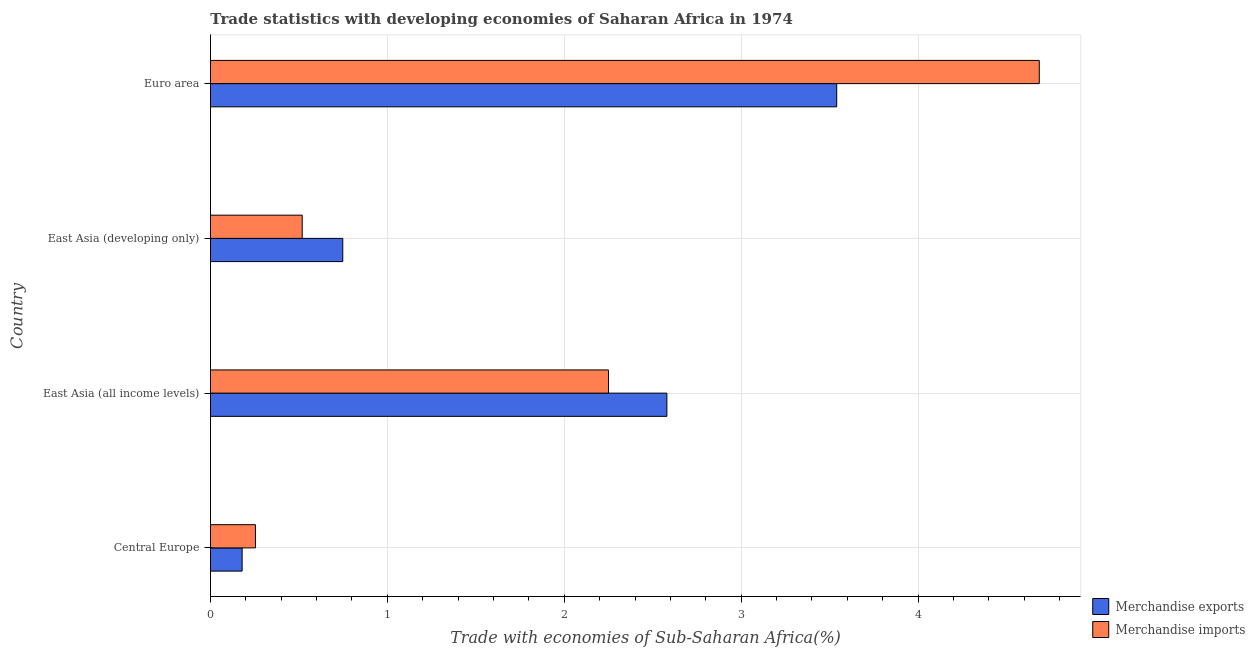How many groups of bars are there?
Offer a terse response. 4. Are the number of bars per tick equal to the number of legend labels?
Your answer should be very brief. Yes. Are the number of bars on each tick of the Y-axis equal?
Provide a short and direct response. Yes. How many bars are there on the 3rd tick from the bottom?
Offer a terse response. 2. What is the label of the 2nd group of bars from the top?
Offer a terse response. East Asia (developing only). In how many cases, is the number of bars for a given country not equal to the number of legend labels?
Provide a succinct answer. 0. What is the merchandise imports in Euro area?
Your answer should be very brief. 4.69. Across all countries, what is the maximum merchandise exports?
Ensure brevity in your answer.  3.54. Across all countries, what is the minimum merchandise imports?
Provide a short and direct response. 0.25. In which country was the merchandise imports minimum?
Make the answer very short. Central Europe. What is the total merchandise imports in the graph?
Provide a succinct answer. 7.71. What is the difference between the merchandise imports in East Asia (all income levels) and that in Euro area?
Your answer should be compact. -2.44. What is the difference between the merchandise imports in East Asia (all income levels) and the merchandise exports in East Asia (developing only)?
Your response must be concise. 1.5. What is the average merchandise exports per country?
Make the answer very short. 1.76. What is the difference between the merchandise imports and merchandise exports in Central Europe?
Keep it short and to the point. 0.07. What is the ratio of the merchandise exports in Central Europe to that in East Asia (all income levels)?
Offer a very short reply. 0.07. Is the difference between the merchandise imports in East Asia (all income levels) and East Asia (developing only) greater than the difference between the merchandise exports in East Asia (all income levels) and East Asia (developing only)?
Give a very brief answer. No. What is the difference between the highest and the second highest merchandise exports?
Your answer should be very brief. 0.96. What is the difference between the highest and the lowest merchandise exports?
Your answer should be compact. 3.36. Is the sum of the merchandise exports in Central Europe and Euro area greater than the maximum merchandise imports across all countries?
Your answer should be very brief. No. What does the 2nd bar from the top in East Asia (all income levels) represents?
Keep it short and to the point. Merchandise exports. How many bars are there?
Your answer should be very brief. 8. Are all the bars in the graph horizontal?
Keep it short and to the point. Yes. What is the difference between two consecutive major ticks on the X-axis?
Keep it short and to the point. 1. Are the values on the major ticks of X-axis written in scientific E-notation?
Provide a short and direct response. No. Does the graph contain any zero values?
Offer a terse response. No. Does the graph contain grids?
Give a very brief answer. Yes. How many legend labels are there?
Provide a short and direct response. 2. How are the legend labels stacked?
Your answer should be very brief. Vertical. What is the title of the graph?
Provide a short and direct response. Trade statistics with developing economies of Saharan Africa in 1974. What is the label or title of the X-axis?
Keep it short and to the point. Trade with economies of Sub-Saharan Africa(%). What is the label or title of the Y-axis?
Offer a terse response. Country. What is the Trade with economies of Sub-Saharan Africa(%) of Merchandise exports in Central Europe?
Offer a terse response. 0.18. What is the Trade with economies of Sub-Saharan Africa(%) in Merchandise imports in Central Europe?
Keep it short and to the point. 0.25. What is the Trade with economies of Sub-Saharan Africa(%) of Merchandise exports in East Asia (all income levels)?
Offer a terse response. 2.58. What is the Trade with economies of Sub-Saharan Africa(%) of Merchandise imports in East Asia (all income levels)?
Make the answer very short. 2.25. What is the Trade with economies of Sub-Saharan Africa(%) in Merchandise exports in East Asia (developing only)?
Make the answer very short. 0.75. What is the Trade with economies of Sub-Saharan Africa(%) in Merchandise imports in East Asia (developing only)?
Offer a very short reply. 0.52. What is the Trade with economies of Sub-Saharan Africa(%) of Merchandise exports in Euro area?
Your answer should be compact. 3.54. What is the Trade with economies of Sub-Saharan Africa(%) in Merchandise imports in Euro area?
Your answer should be compact. 4.69. Across all countries, what is the maximum Trade with economies of Sub-Saharan Africa(%) in Merchandise exports?
Your answer should be very brief. 3.54. Across all countries, what is the maximum Trade with economies of Sub-Saharan Africa(%) in Merchandise imports?
Provide a succinct answer. 4.69. Across all countries, what is the minimum Trade with economies of Sub-Saharan Africa(%) in Merchandise exports?
Ensure brevity in your answer.  0.18. Across all countries, what is the minimum Trade with economies of Sub-Saharan Africa(%) of Merchandise imports?
Offer a very short reply. 0.25. What is the total Trade with economies of Sub-Saharan Africa(%) in Merchandise exports in the graph?
Your response must be concise. 7.05. What is the total Trade with economies of Sub-Saharan Africa(%) of Merchandise imports in the graph?
Offer a very short reply. 7.71. What is the difference between the Trade with economies of Sub-Saharan Africa(%) of Merchandise exports in Central Europe and that in East Asia (all income levels)?
Give a very brief answer. -2.4. What is the difference between the Trade with economies of Sub-Saharan Africa(%) of Merchandise imports in Central Europe and that in East Asia (all income levels)?
Provide a succinct answer. -2. What is the difference between the Trade with economies of Sub-Saharan Africa(%) in Merchandise exports in Central Europe and that in East Asia (developing only)?
Your answer should be compact. -0.57. What is the difference between the Trade with economies of Sub-Saharan Africa(%) in Merchandise imports in Central Europe and that in East Asia (developing only)?
Make the answer very short. -0.26. What is the difference between the Trade with economies of Sub-Saharan Africa(%) of Merchandise exports in Central Europe and that in Euro area?
Make the answer very short. -3.36. What is the difference between the Trade with economies of Sub-Saharan Africa(%) in Merchandise imports in Central Europe and that in Euro area?
Give a very brief answer. -4.43. What is the difference between the Trade with economies of Sub-Saharan Africa(%) of Merchandise exports in East Asia (all income levels) and that in East Asia (developing only)?
Provide a short and direct response. 1.83. What is the difference between the Trade with economies of Sub-Saharan Africa(%) in Merchandise imports in East Asia (all income levels) and that in East Asia (developing only)?
Keep it short and to the point. 1.73. What is the difference between the Trade with economies of Sub-Saharan Africa(%) of Merchandise exports in East Asia (all income levels) and that in Euro area?
Ensure brevity in your answer.  -0.96. What is the difference between the Trade with economies of Sub-Saharan Africa(%) in Merchandise imports in East Asia (all income levels) and that in Euro area?
Provide a succinct answer. -2.44. What is the difference between the Trade with economies of Sub-Saharan Africa(%) in Merchandise exports in East Asia (developing only) and that in Euro area?
Give a very brief answer. -2.79. What is the difference between the Trade with economies of Sub-Saharan Africa(%) of Merchandise imports in East Asia (developing only) and that in Euro area?
Provide a short and direct response. -4.17. What is the difference between the Trade with economies of Sub-Saharan Africa(%) in Merchandise exports in Central Europe and the Trade with economies of Sub-Saharan Africa(%) in Merchandise imports in East Asia (all income levels)?
Provide a succinct answer. -2.07. What is the difference between the Trade with economies of Sub-Saharan Africa(%) in Merchandise exports in Central Europe and the Trade with economies of Sub-Saharan Africa(%) in Merchandise imports in East Asia (developing only)?
Provide a succinct answer. -0.34. What is the difference between the Trade with economies of Sub-Saharan Africa(%) in Merchandise exports in Central Europe and the Trade with economies of Sub-Saharan Africa(%) in Merchandise imports in Euro area?
Ensure brevity in your answer.  -4.51. What is the difference between the Trade with economies of Sub-Saharan Africa(%) in Merchandise exports in East Asia (all income levels) and the Trade with economies of Sub-Saharan Africa(%) in Merchandise imports in East Asia (developing only)?
Ensure brevity in your answer.  2.06. What is the difference between the Trade with economies of Sub-Saharan Africa(%) in Merchandise exports in East Asia (all income levels) and the Trade with economies of Sub-Saharan Africa(%) in Merchandise imports in Euro area?
Make the answer very short. -2.11. What is the difference between the Trade with economies of Sub-Saharan Africa(%) in Merchandise exports in East Asia (developing only) and the Trade with economies of Sub-Saharan Africa(%) in Merchandise imports in Euro area?
Give a very brief answer. -3.94. What is the average Trade with economies of Sub-Saharan Africa(%) in Merchandise exports per country?
Offer a very short reply. 1.76. What is the average Trade with economies of Sub-Saharan Africa(%) in Merchandise imports per country?
Offer a terse response. 1.93. What is the difference between the Trade with economies of Sub-Saharan Africa(%) in Merchandise exports and Trade with economies of Sub-Saharan Africa(%) in Merchandise imports in Central Europe?
Your response must be concise. -0.08. What is the difference between the Trade with economies of Sub-Saharan Africa(%) in Merchandise exports and Trade with economies of Sub-Saharan Africa(%) in Merchandise imports in East Asia (all income levels)?
Provide a succinct answer. 0.33. What is the difference between the Trade with economies of Sub-Saharan Africa(%) of Merchandise exports and Trade with economies of Sub-Saharan Africa(%) of Merchandise imports in East Asia (developing only)?
Provide a succinct answer. 0.23. What is the difference between the Trade with economies of Sub-Saharan Africa(%) of Merchandise exports and Trade with economies of Sub-Saharan Africa(%) of Merchandise imports in Euro area?
Your answer should be compact. -1.15. What is the ratio of the Trade with economies of Sub-Saharan Africa(%) in Merchandise exports in Central Europe to that in East Asia (all income levels)?
Provide a succinct answer. 0.07. What is the ratio of the Trade with economies of Sub-Saharan Africa(%) of Merchandise imports in Central Europe to that in East Asia (all income levels)?
Your answer should be compact. 0.11. What is the ratio of the Trade with economies of Sub-Saharan Africa(%) in Merchandise exports in Central Europe to that in East Asia (developing only)?
Give a very brief answer. 0.24. What is the ratio of the Trade with economies of Sub-Saharan Africa(%) in Merchandise imports in Central Europe to that in East Asia (developing only)?
Your answer should be compact. 0.49. What is the ratio of the Trade with economies of Sub-Saharan Africa(%) of Merchandise exports in Central Europe to that in Euro area?
Offer a terse response. 0.05. What is the ratio of the Trade with economies of Sub-Saharan Africa(%) in Merchandise imports in Central Europe to that in Euro area?
Make the answer very short. 0.05. What is the ratio of the Trade with economies of Sub-Saharan Africa(%) in Merchandise exports in East Asia (all income levels) to that in East Asia (developing only)?
Your answer should be very brief. 3.45. What is the ratio of the Trade with economies of Sub-Saharan Africa(%) of Merchandise imports in East Asia (all income levels) to that in East Asia (developing only)?
Provide a short and direct response. 4.34. What is the ratio of the Trade with economies of Sub-Saharan Africa(%) in Merchandise exports in East Asia (all income levels) to that in Euro area?
Provide a succinct answer. 0.73. What is the ratio of the Trade with economies of Sub-Saharan Africa(%) in Merchandise imports in East Asia (all income levels) to that in Euro area?
Provide a short and direct response. 0.48. What is the ratio of the Trade with economies of Sub-Saharan Africa(%) in Merchandise exports in East Asia (developing only) to that in Euro area?
Provide a succinct answer. 0.21. What is the ratio of the Trade with economies of Sub-Saharan Africa(%) of Merchandise imports in East Asia (developing only) to that in Euro area?
Provide a short and direct response. 0.11. What is the difference between the highest and the second highest Trade with economies of Sub-Saharan Africa(%) of Merchandise exports?
Provide a short and direct response. 0.96. What is the difference between the highest and the second highest Trade with economies of Sub-Saharan Africa(%) of Merchandise imports?
Provide a succinct answer. 2.44. What is the difference between the highest and the lowest Trade with economies of Sub-Saharan Africa(%) in Merchandise exports?
Provide a short and direct response. 3.36. What is the difference between the highest and the lowest Trade with economies of Sub-Saharan Africa(%) in Merchandise imports?
Provide a short and direct response. 4.43. 